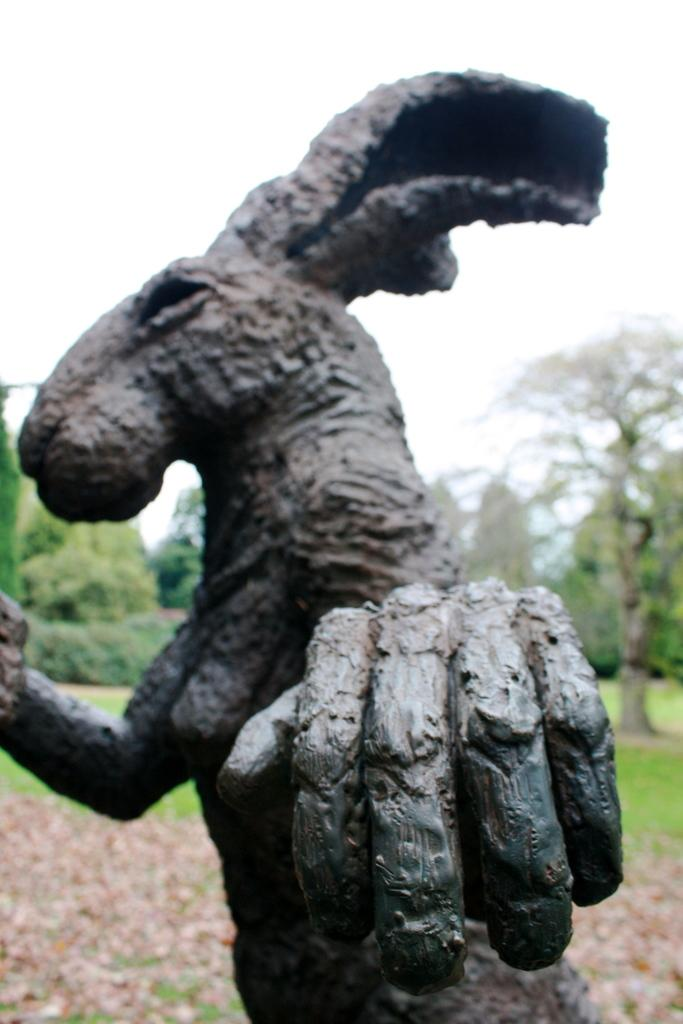What is the main subject in the front of the image? There is an animal statue in the front of the image. What can be seen in the background of the image? There are trees in the background of the image. What is visible at the top of the image? The sky is visible at the top of the image. What type of behavior does the animal statue exhibit in the image? The animal statue is a stationary object and does not exhibit any behavior in the image. 